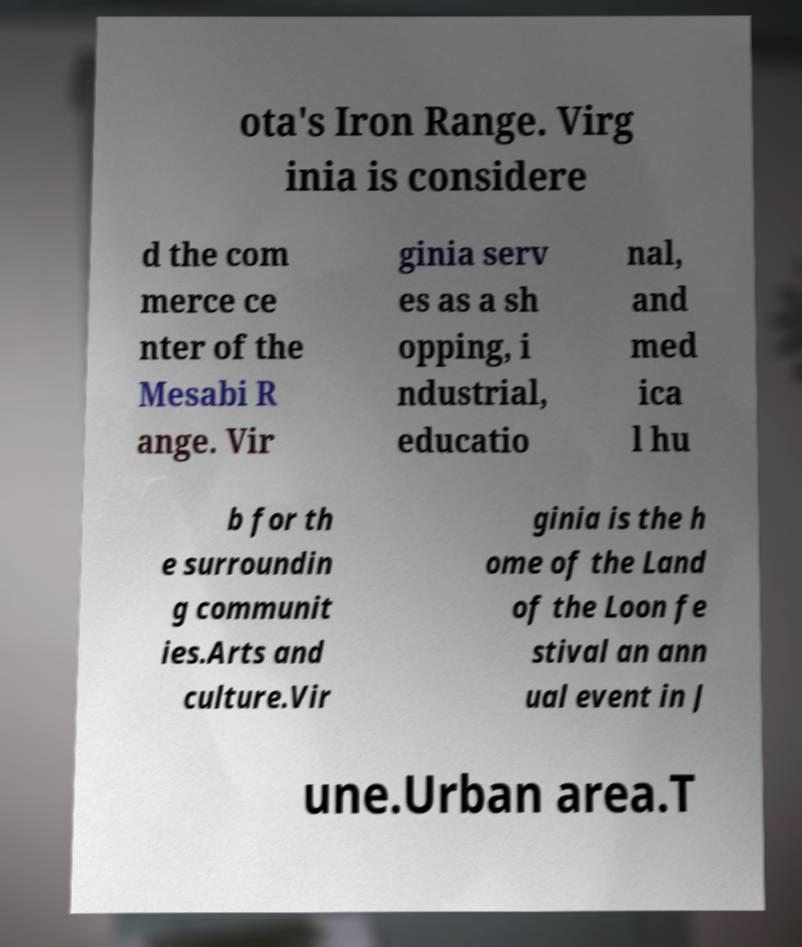Could you extract and type out the text from this image? ota's Iron Range. Virg inia is considere d the com merce ce nter of the Mesabi R ange. Vir ginia serv es as a sh opping, i ndustrial, educatio nal, and med ica l hu b for th e surroundin g communit ies.Arts and culture.Vir ginia is the h ome of the Land of the Loon fe stival an ann ual event in J une.Urban area.T 